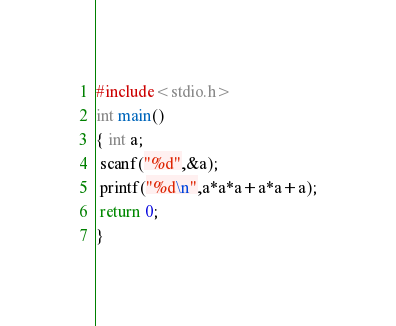<code> <loc_0><loc_0><loc_500><loc_500><_C_>#include<stdio.h>
int main()
{ int a;
 scanf("%d",&a);
 printf("%d\n",a*a*a+a*a+a);
 return 0;
}</code> 